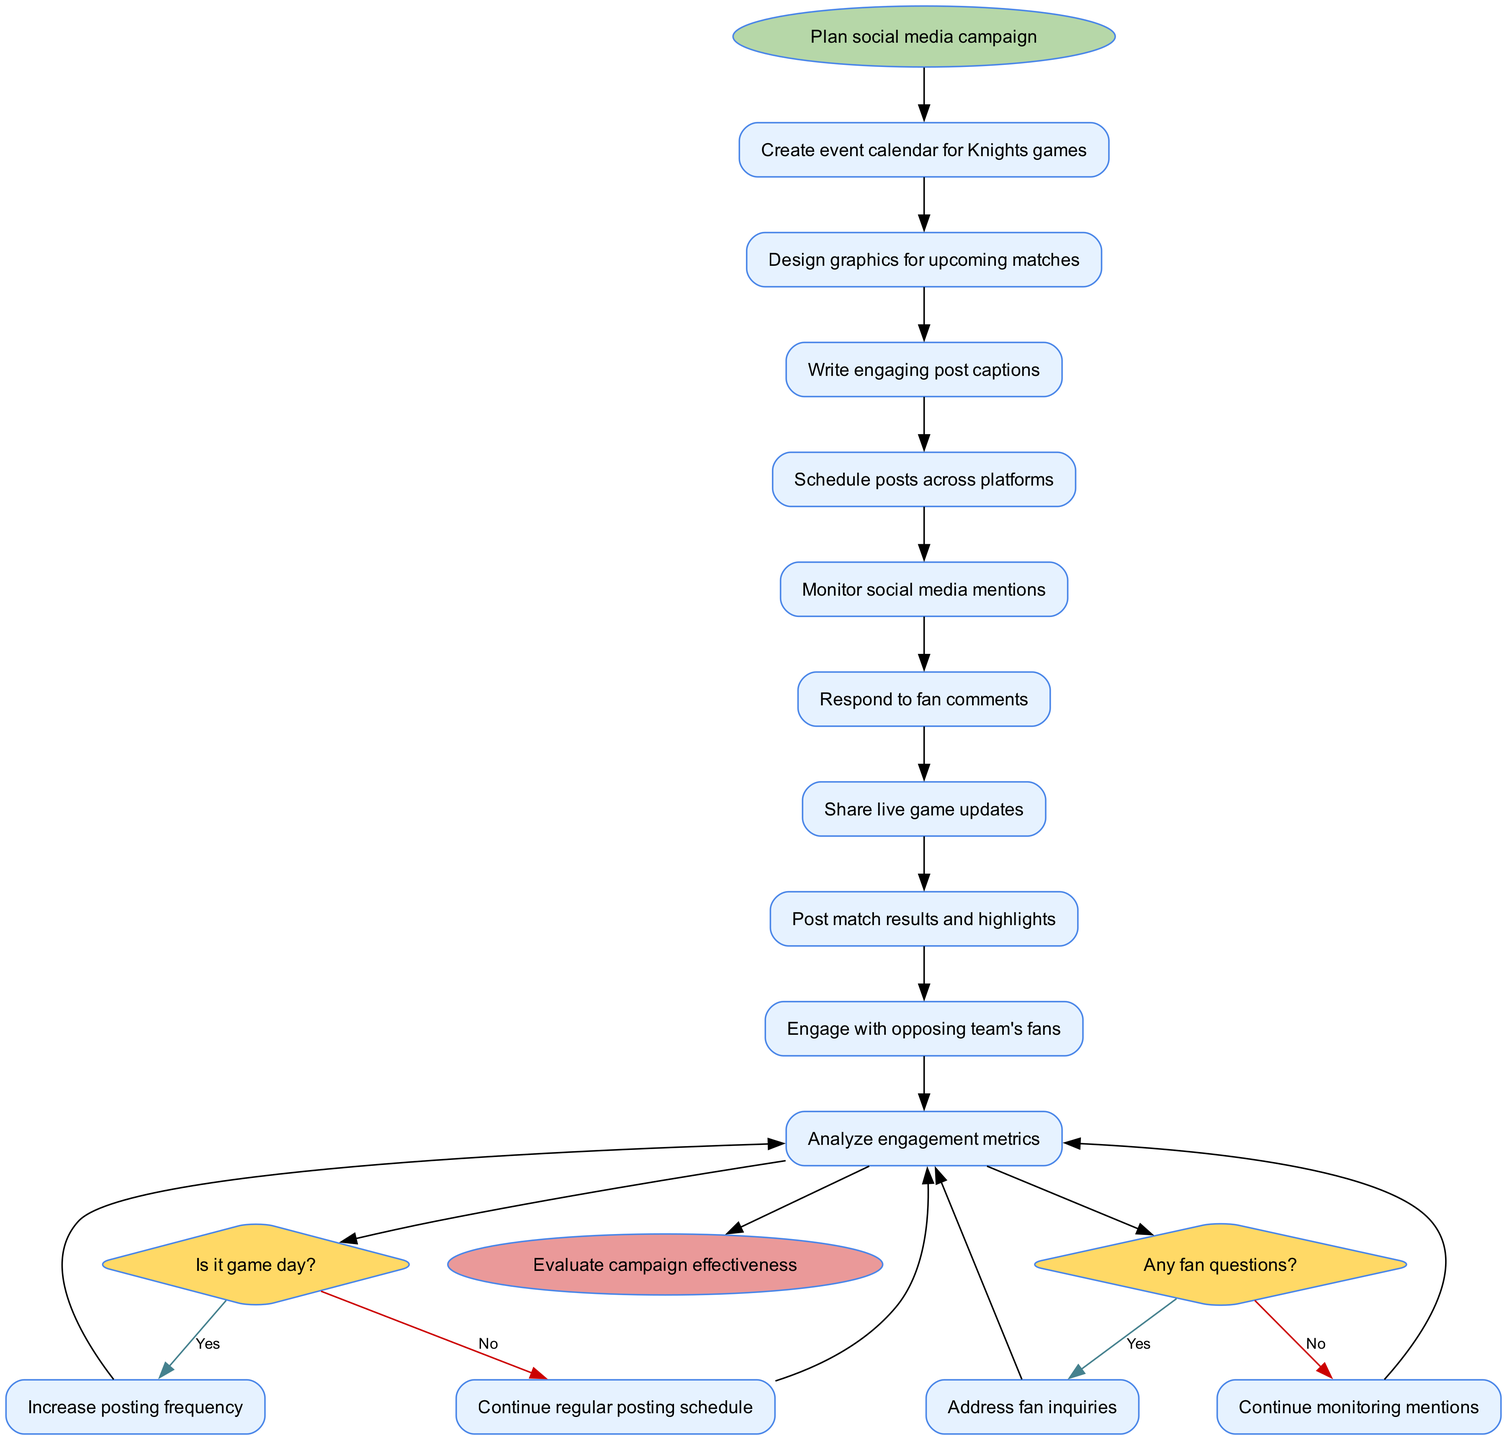What is the starting activity in this workflow? The starting point in the diagram, represented by the start node, is the first activity "Plan social media campaign". It sets the stage for the subsequent actions in the workflow.
Answer: Plan social media campaign How many activities are there in total? By counting the distinct actions listed in the activities section, there are nine activities: creating an event calendar, designing graphics, writing captions, scheduling posts, monitoring mentions, responding to comments, sharing updates, posting results, and engaging with fans.
Answer: 9 What happens if it is game day? According to the decision node regarding whether it's game day, the response indicates that the workflow will "Increase posting frequency" if the answer is yes, which impacts how social media engagement is managed on that day.
Answer: Increase posting frequency What is the end node of the workflow? The final point in the diagram, indicated by the end node, summarizes the workflow's conclusion as "Evaluate campaign effectiveness", which is the process of assessing the success of the social media engagement efforts.
Answer: Evaluate campaign effectiveness What should be done if fan questions arise? The decision node indicates that if fan questions are present, the next step would be to "Address fan inquiries", thereby ensuring active interaction with the community and addressing their needs promptly.
Answer: Address fan inquiries What is the relationship between posting updates and the number of activities? The posting of live game updates is one of the nine activities, and it is interconnected with the engagement strategy as it occurs as part of the regular post-scheduling process. The relationship emphasizes real-time interaction during games.
Answer: Live game updates are one of the nine activities What decision follows the last activity in the workflow? The last activity before the decision nodes is typically about engaging with opposing team's fans, which leads to the decision question of whether it is game day. This indicates that ongoing interactions are monitored and adjusted based on the day of the game.
Answer: Is it game day? What do you do if there are no fan questions? As indicated in the decision-making process, if the answer to the question of fan inquiries is no, the workflow continues to "Continue monitoring mentions", which ensures that the engagement process remains active even without direct questions.
Answer: Continue monitoring mentions 